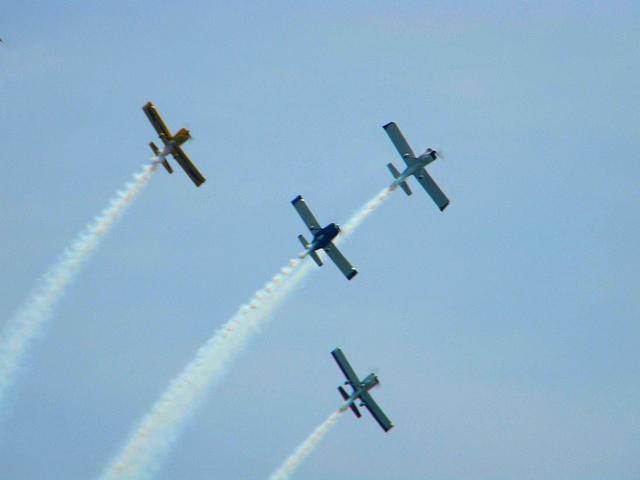Do all the planes have  a smoke trail?
Write a very short answer. Yes. How many planes are flying?
Keep it brief. 4. Is this a formation of fighter planes?
Write a very short answer. Yes. How many engines do these planes have?
Write a very short answer. 2. 